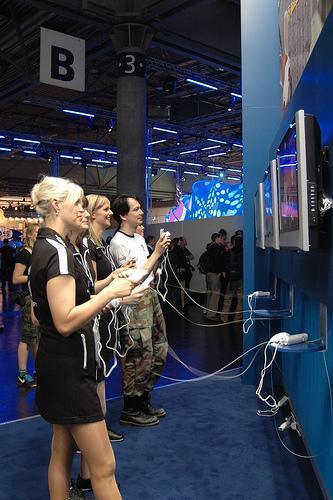How many women are standing in front of video game monitors?
Give a very brief answer. 3. 